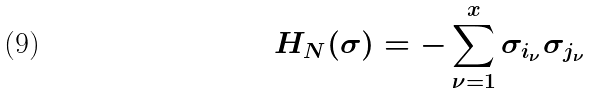Convert formula to latex. <formula><loc_0><loc_0><loc_500><loc_500>H _ { N } ( \sigma ) = - \sum _ { \nu = 1 } ^ { x } \sigma _ { i _ { \nu } } \sigma _ { j _ { \nu } }</formula> 